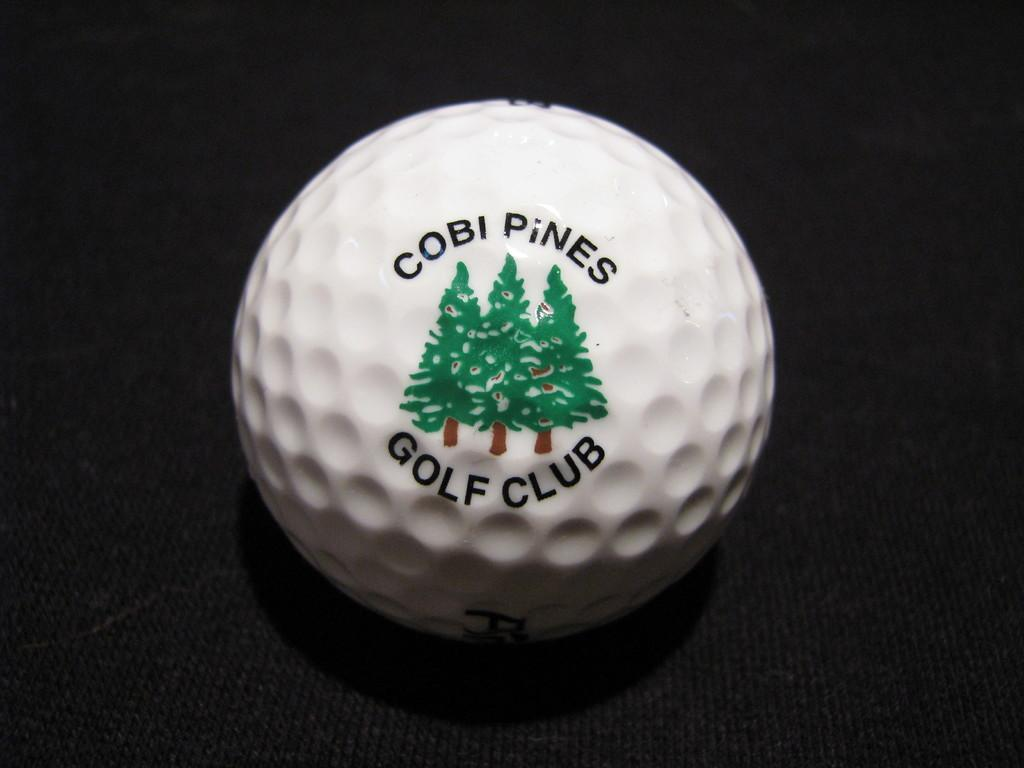What is the main subject of the image? The main subject of the image is a ball. What is on the surface of the ball? There is text and a painting on the ball. How many goldfish can be seen swimming around the ball in the image? There are no goldfish present in the image; it features a ball with text and a painting. What time is displayed on the clock painted on the ball in the image? There is no clock present on the ball in the image; it only features text and a painting. 